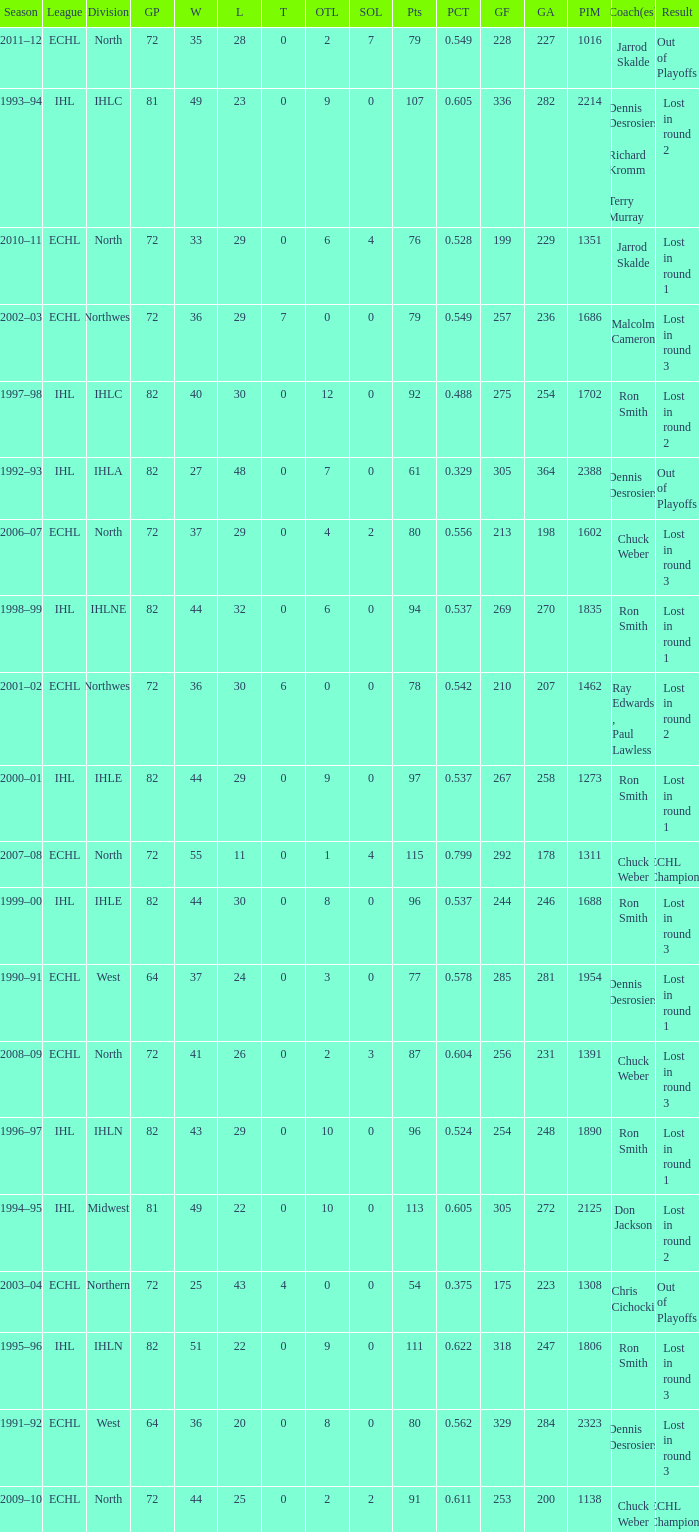What was the season where the team reached a GP of 244? 1999–00. Can you parse all the data within this table? {'header': ['Season', 'League', 'Division', 'GP', 'W', 'L', 'T', 'OTL', 'SOL', 'Pts', 'PCT', 'GF', 'GA', 'PIM', 'Coach(es)', 'Result'], 'rows': [['2011–12', 'ECHL', 'North', '72', '35', '28', '0', '2', '7', '79', '0.549', '228', '227', '1016', 'Jarrod Skalde', 'Out of Playoffs'], ['1993–94', 'IHL', 'IHLC', '81', '49', '23', '0', '9', '0', '107', '0.605', '336', '282', '2214', 'Dennis Desrosiers , Richard Kromm , Terry Murray', 'Lost in round 2'], ['2010–11', 'ECHL', 'North', '72', '33', '29', '0', '6', '4', '76', '0.528', '199', '229', '1351', 'Jarrod Skalde', 'Lost in round 1'], ['2002–03', 'ECHL', 'Northwest', '72', '36', '29', '7', '0', '0', '79', '0.549', '257', '236', '1686', 'Malcolm Cameron', 'Lost in round 3'], ['1997–98', 'IHL', 'IHLC', '82', '40', '30', '0', '12', '0', '92', '0.488', '275', '254', '1702', 'Ron Smith', 'Lost in round 2'], ['1992–93', 'IHL', 'IHLA', '82', '27', '48', '0', '7', '0', '61', '0.329', '305', '364', '2388', 'Dennis Desrosiers', 'Out of Playoffs'], ['2006–07', 'ECHL', 'North', '72', '37', '29', '0', '4', '2', '80', '0.556', '213', '198', '1602', 'Chuck Weber', 'Lost in round 3'], ['1998–99', 'IHL', 'IHLNE', '82', '44', '32', '0', '6', '0', '94', '0.537', '269', '270', '1835', 'Ron Smith', 'Lost in round 1'], ['2001–02', 'ECHL', 'Northwest', '72', '36', '30', '6', '0', '0', '78', '0.542', '210', '207', '1462', 'Ray Edwards , Paul Lawless', 'Lost in round 2'], ['2000–01', 'IHL', 'IHLE', '82', '44', '29', '0', '9', '0', '97', '0.537', '267', '258', '1273', 'Ron Smith', 'Lost in round 1'], ['2007–08', 'ECHL', 'North', '72', '55', '11', '0', '1', '4', '115', '0.799', '292', '178', '1311', 'Chuck Weber', 'ECHL Champions'], ['1999–00', 'IHL', 'IHLE', '82', '44', '30', '0', '8', '0', '96', '0.537', '244', '246', '1688', 'Ron Smith', 'Lost in round 3'], ['1990–91', 'ECHL', 'West', '64', '37', '24', '0', '3', '0', '77', '0.578', '285', '281', '1954', 'Dennis Desrosiers', 'Lost in round 1'], ['2008–09', 'ECHL', 'North', '72', '41', '26', '0', '2', '3', '87', '0.604', '256', '231', '1391', 'Chuck Weber', 'Lost in round 3'], ['1996–97', 'IHL', 'IHLN', '82', '43', '29', '0', '10', '0', '96', '0.524', '254', '248', '1890', 'Ron Smith', 'Lost in round 1'], ['1994–95', 'IHL', 'Midwest', '81', '49', '22', '0', '10', '0', '113', '0.605', '305', '272', '2125', 'Don Jackson', 'Lost in round 2'], ['2003–04', 'ECHL', 'Northern', '72', '25', '43', '4', '0', '0', '54', '0.375', '175', '223', '1308', 'Chris Cichocki', 'Out of Playoffs'], ['1995–96', 'IHL', 'IHLN', '82', '51', '22', '0', '9', '0', '111', '0.622', '318', '247', '1806', 'Ron Smith', 'Lost in round 3'], ['1991–92', 'ECHL', 'West', '64', '36', '20', '0', '8', '0', '80', '0.562', '329', '284', '2323', 'Dennis Desrosiers', 'Lost in round 3'], ['2009–10', 'ECHL', 'North', '72', '44', '25', '0', '2', '2', '91', '0.611', '253', '200', '1138', 'Chuck Weber', 'ECHL Champions']]} 